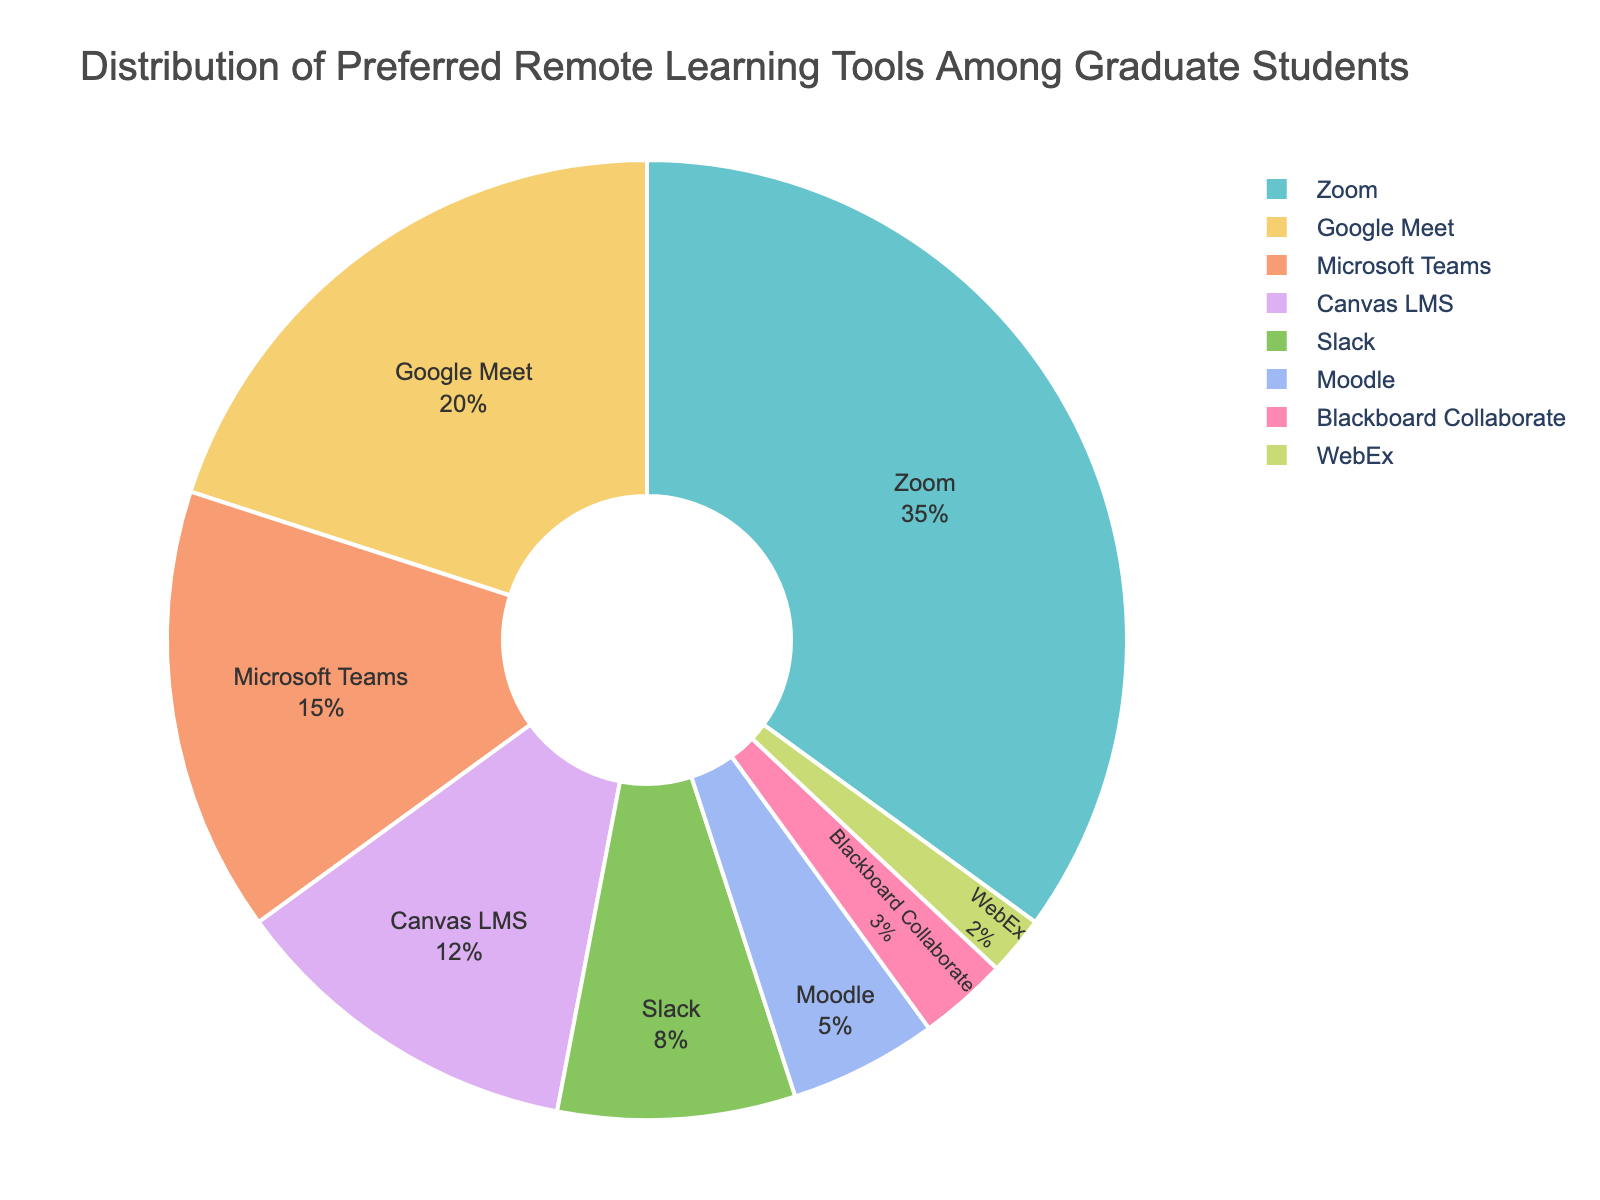Which tool is preferred by the highest percentage of graduate students? The figure shows a pie chart where each segment represents a remote learning tool and its corresponding percentage of preference among graduate students. The largest segment is for Zoom, which is highlighted as 35%.
Answer: Zoom Which two tools together cover exactly half of the preferences of graduate students? To find the two tools that together cover 50%, we need to consider adding percentages. Zoom (35%) and Google Meet (20%) sum up to 55%, but that's more than half. Therefore, the next pair to try is Zoom (35%) and Microsoft Teams (15%), which sum up to 50%.
Answer: Zoom and Microsoft Teams How much more popular is Google Meet compared to Slack? To find how much more popular Google Meet is compared to Slack, we subtract the percentage of Slack from that of Google Meet. Google Meet is 20%, and Slack is 8%, so the difference is 20% - 8% = 12%.
Answer: 12% What is the combined percentage of the least preferred tools? The least preferred tools are Blackboard Collaborate and WebEx. Adding their percentages gives us 3% + 2% = 5%.
Answer: 5% Which tool has the second smallest percentage and what is that percentage? Examining the pie chart, Moodle has 5% and WebEx has 2%. Since WebEx has the smallest percentage, Moodle has the second smallest percentage at 5%.
Answer: Moodle, 5% If Zoom's preference decreased by 10% and Canvas LMS increased by 10%, which tool would then become the most preferred? After decreasing by 10%, Zoom's new preference would be 35% - 10% = 25%. Canvas LMS would then have 12% + 10% = 22%. Since the new preference for Zoom (25%) is still higher than that of the other tools, Zoom would continue to be the most preferred tool.
Answer: Zoom Is the preference of Microsoft Teams greater than the combined preference of Moodle and Blackboard Collaborate? Microsoft Teams has a percentage of 15%, while Moodle and Blackboard Collaborate combined have 5% + 3% = 8%. Since 15% is greater than 8%, Microsoft Teams is indeed more preferred.
Answer: Yes What percentage of students prefer tools other than Zoom, Google Meet, and Microsoft Teams? To find this, we need to sum the percentages of the other tools: Canvas LMS (12%), Slack (8%), Moodle (5%), Blackboard Collaborate (3%), and WebEx (2%). Adding these yields 12% + 8% + 5% + 3% + 2% = 30%.
Answer: 30% Which tool has a percentage closest to one-fifth of the total preferences? One-fifth of the total is 20%. Google Meet is 20%, which matches exactly one-fifth of the total preferences.
Answer: Google Meet 